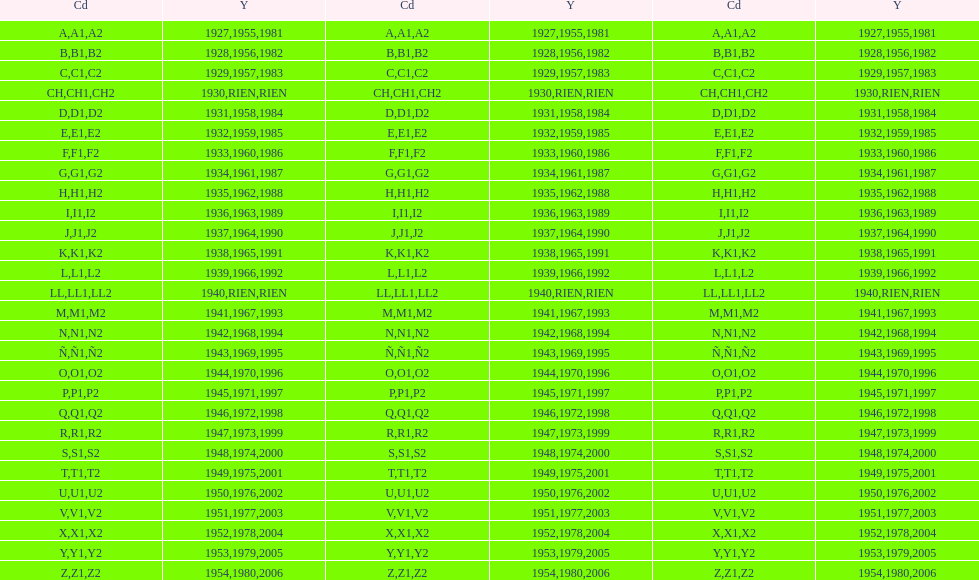Other than 1927 what year did the code start with a? 1955, 1981. 